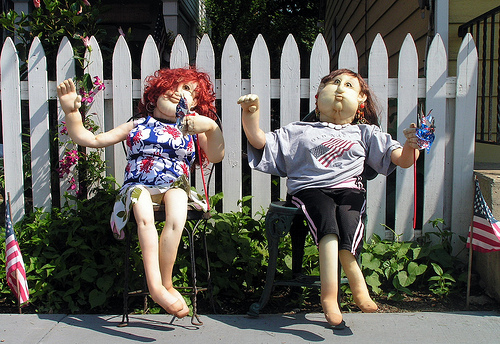<image>
Can you confirm if the doll is in front of the fence? Yes. The doll is positioned in front of the fence, appearing closer to the camera viewpoint. 